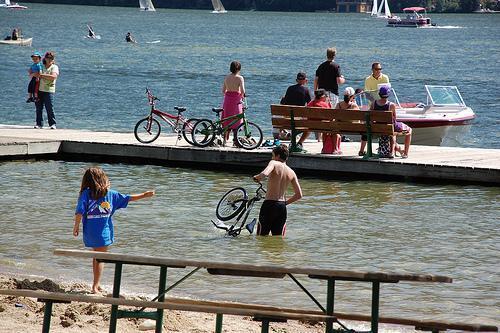How many bikes are pictured?
Give a very brief answer. 3. How many bicycles are on the dock?
Give a very brief answer. 2. How many people are wearing blue shirt?
Give a very brief answer. 1. 